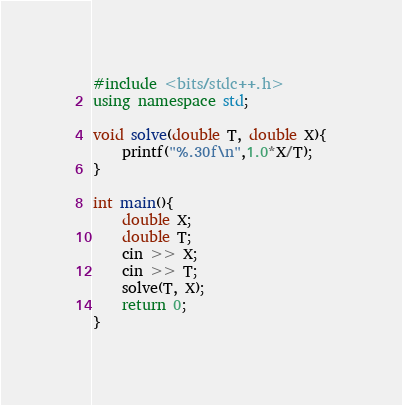Convert code to text. <code><loc_0><loc_0><loc_500><loc_500><_C++_>#include <bits/stdc++.h>
using namespace std;

void solve(double T, double X){
	printf("%.30f\n",1.0*X/T);
}

int main(){
	double X;
	double T;
	cin >> X;
	cin >> T;
	solve(T, X);
	return 0;
}
</code> 